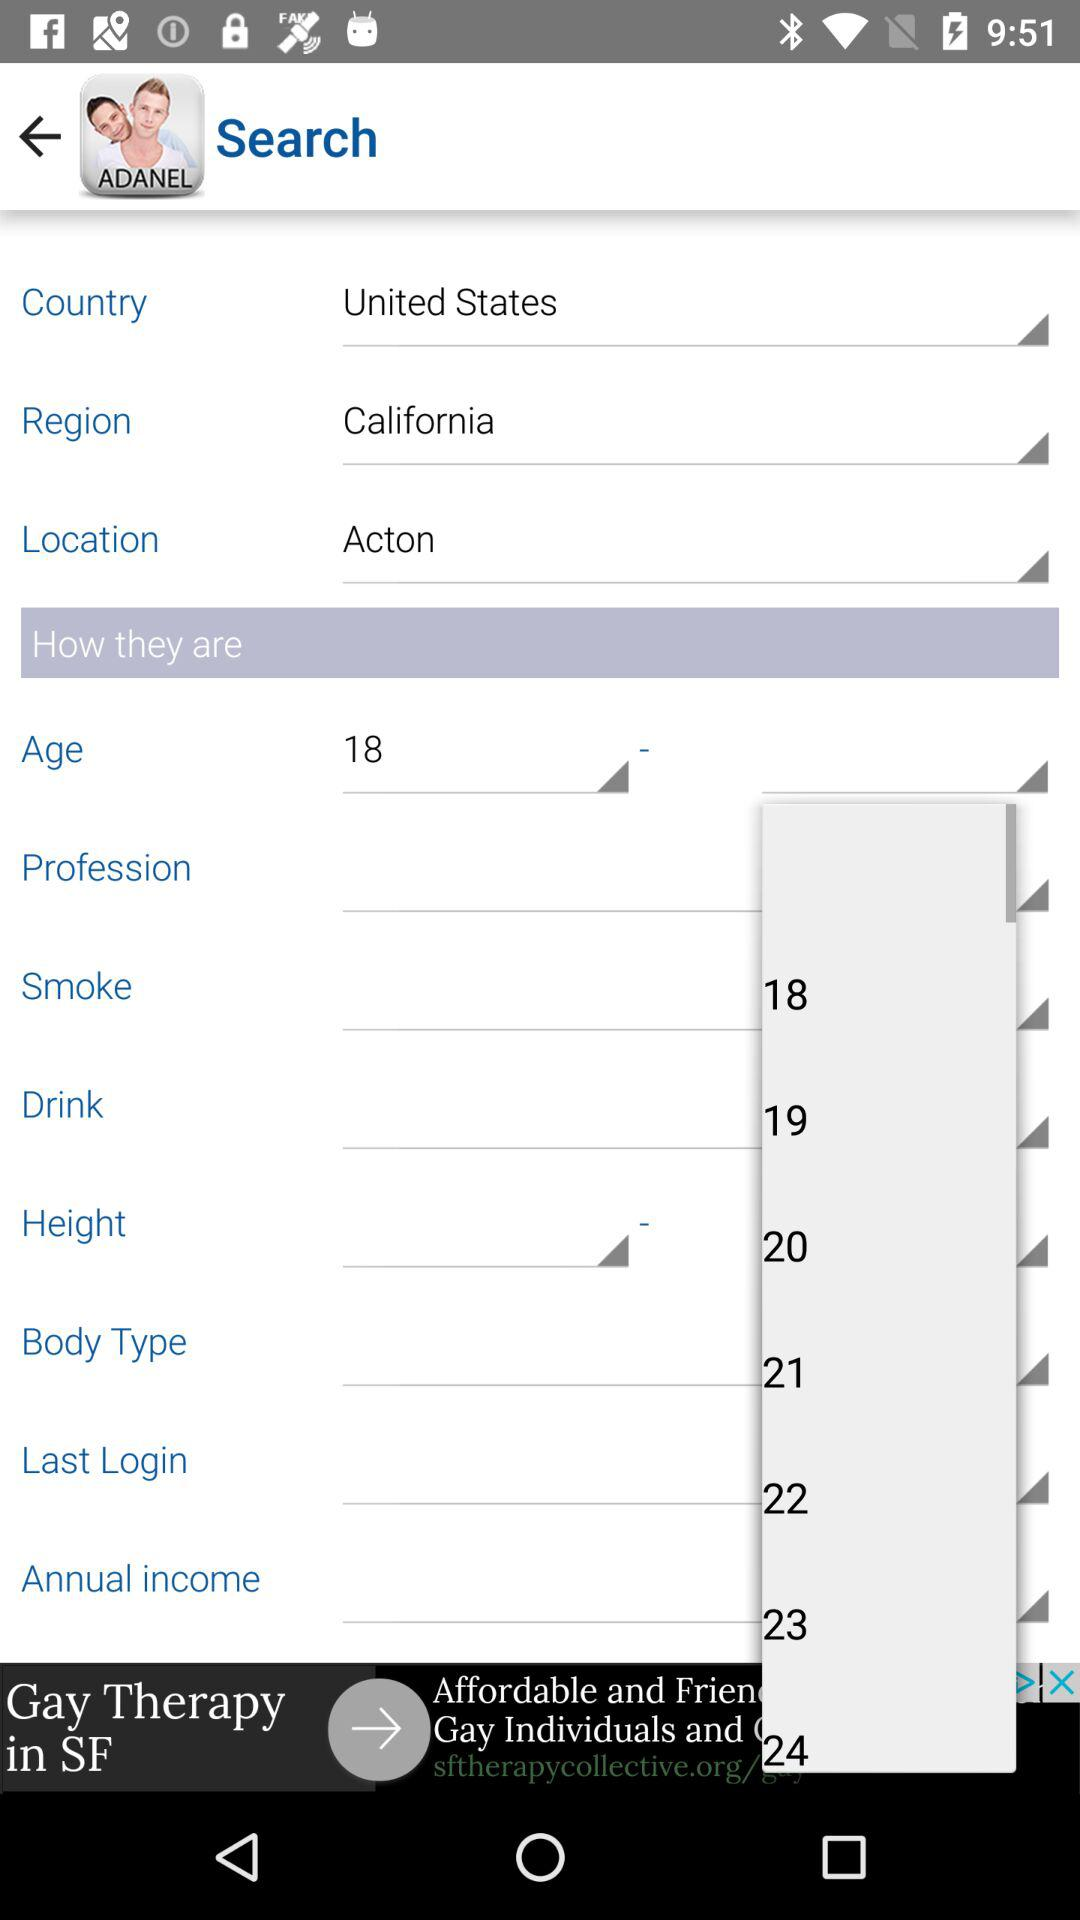What is the selected country? The selected country is the United States. 